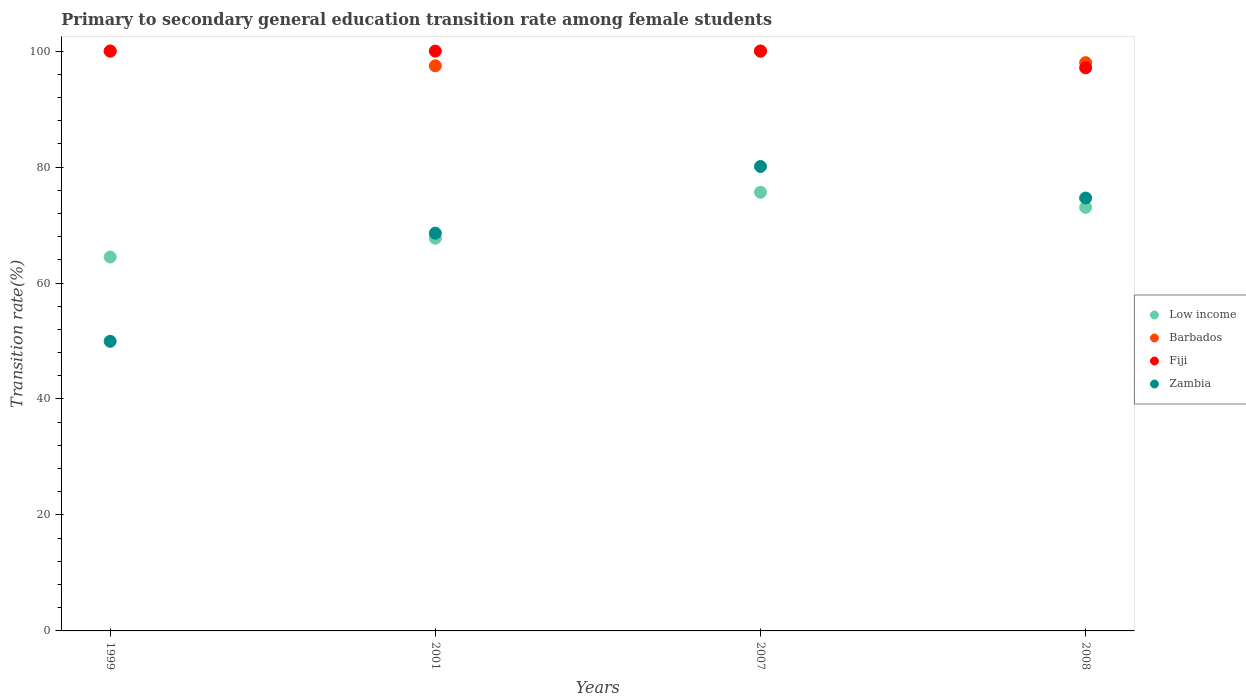How many different coloured dotlines are there?
Your answer should be very brief. 4. What is the transition rate in Low income in 2001?
Offer a terse response. 67.72. Across all years, what is the maximum transition rate in Barbados?
Keep it short and to the point. 100. Across all years, what is the minimum transition rate in Barbados?
Your answer should be compact. 97.46. In which year was the transition rate in Zambia maximum?
Ensure brevity in your answer.  2007. In which year was the transition rate in Zambia minimum?
Offer a very short reply. 1999. What is the total transition rate in Barbados in the graph?
Make the answer very short. 395.46. What is the difference between the transition rate in Zambia in 2001 and that in 2007?
Offer a very short reply. -11.5. What is the difference between the transition rate in Barbados in 1999 and the transition rate in Zambia in 2001?
Offer a very short reply. 31.4. What is the average transition rate in Barbados per year?
Keep it short and to the point. 98.87. In the year 2007, what is the difference between the transition rate in Barbados and transition rate in Zambia?
Your answer should be very brief. 19.9. What is the ratio of the transition rate in Low income in 1999 to that in 2007?
Your answer should be compact. 0.85. Is the transition rate in Zambia in 2007 less than that in 2008?
Make the answer very short. No. What is the difference between the highest and the second highest transition rate in Fiji?
Ensure brevity in your answer.  0. What is the difference between the highest and the lowest transition rate in Zambia?
Make the answer very short. 30.15. In how many years, is the transition rate in Barbados greater than the average transition rate in Barbados taken over all years?
Ensure brevity in your answer.  2. Is the sum of the transition rate in Zambia in 2001 and 2008 greater than the maximum transition rate in Low income across all years?
Provide a succinct answer. Yes. Does the transition rate in Fiji monotonically increase over the years?
Offer a very short reply. No. How many dotlines are there?
Offer a very short reply. 4. How many years are there in the graph?
Your answer should be compact. 4. What is the difference between two consecutive major ticks on the Y-axis?
Your response must be concise. 20. Are the values on the major ticks of Y-axis written in scientific E-notation?
Give a very brief answer. No. Does the graph contain any zero values?
Offer a terse response. No. Does the graph contain grids?
Provide a succinct answer. No. How are the legend labels stacked?
Make the answer very short. Vertical. What is the title of the graph?
Keep it short and to the point. Primary to secondary general education transition rate among female students. Does "Ethiopia" appear as one of the legend labels in the graph?
Keep it short and to the point. No. What is the label or title of the X-axis?
Make the answer very short. Years. What is the label or title of the Y-axis?
Offer a very short reply. Transition rate(%). What is the Transition rate(%) of Low income in 1999?
Provide a short and direct response. 64.48. What is the Transition rate(%) in Fiji in 1999?
Offer a terse response. 100. What is the Transition rate(%) of Zambia in 1999?
Your response must be concise. 49.95. What is the Transition rate(%) of Low income in 2001?
Provide a succinct answer. 67.72. What is the Transition rate(%) in Barbados in 2001?
Give a very brief answer. 97.46. What is the Transition rate(%) of Fiji in 2001?
Make the answer very short. 100. What is the Transition rate(%) of Zambia in 2001?
Make the answer very short. 68.6. What is the Transition rate(%) of Low income in 2007?
Your response must be concise. 75.65. What is the Transition rate(%) in Fiji in 2007?
Your response must be concise. 100. What is the Transition rate(%) of Zambia in 2007?
Offer a terse response. 80.1. What is the Transition rate(%) in Low income in 2008?
Offer a very short reply. 73.05. What is the Transition rate(%) in Barbados in 2008?
Offer a very short reply. 98. What is the Transition rate(%) of Fiji in 2008?
Ensure brevity in your answer.  97.11. What is the Transition rate(%) in Zambia in 2008?
Offer a very short reply. 74.66. Across all years, what is the maximum Transition rate(%) of Low income?
Offer a very short reply. 75.65. Across all years, what is the maximum Transition rate(%) in Barbados?
Your answer should be very brief. 100. Across all years, what is the maximum Transition rate(%) in Fiji?
Give a very brief answer. 100. Across all years, what is the maximum Transition rate(%) in Zambia?
Your answer should be compact. 80.1. Across all years, what is the minimum Transition rate(%) of Low income?
Provide a short and direct response. 64.48. Across all years, what is the minimum Transition rate(%) in Barbados?
Keep it short and to the point. 97.46. Across all years, what is the minimum Transition rate(%) of Fiji?
Your response must be concise. 97.11. Across all years, what is the minimum Transition rate(%) of Zambia?
Make the answer very short. 49.95. What is the total Transition rate(%) in Low income in the graph?
Provide a short and direct response. 280.91. What is the total Transition rate(%) of Barbados in the graph?
Provide a short and direct response. 395.46. What is the total Transition rate(%) of Fiji in the graph?
Keep it short and to the point. 397.11. What is the total Transition rate(%) in Zambia in the graph?
Your response must be concise. 273.3. What is the difference between the Transition rate(%) in Low income in 1999 and that in 2001?
Offer a very short reply. -3.24. What is the difference between the Transition rate(%) in Barbados in 1999 and that in 2001?
Your answer should be compact. 2.54. What is the difference between the Transition rate(%) in Fiji in 1999 and that in 2001?
Provide a succinct answer. 0. What is the difference between the Transition rate(%) of Zambia in 1999 and that in 2001?
Your answer should be compact. -18.65. What is the difference between the Transition rate(%) in Low income in 1999 and that in 2007?
Give a very brief answer. -11.17. What is the difference between the Transition rate(%) of Barbados in 1999 and that in 2007?
Give a very brief answer. 0. What is the difference between the Transition rate(%) in Zambia in 1999 and that in 2007?
Provide a succinct answer. -30.15. What is the difference between the Transition rate(%) of Low income in 1999 and that in 2008?
Provide a short and direct response. -8.57. What is the difference between the Transition rate(%) of Barbados in 1999 and that in 2008?
Offer a very short reply. 2. What is the difference between the Transition rate(%) of Fiji in 1999 and that in 2008?
Give a very brief answer. 2.89. What is the difference between the Transition rate(%) in Zambia in 1999 and that in 2008?
Provide a succinct answer. -24.71. What is the difference between the Transition rate(%) of Low income in 2001 and that in 2007?
Offer a terse response. -7.93. What is the difference between the Transition rate(%) in Barbados in 2001 and that in 2007?
Make the answer very short. -2.54. What is the difference between the Transition rate(%) of Fiji in 2001 and that in 2007?
Offer a terse response. 0. What is the difference between the Transition rate(%) in Zambia in 2001 and that in 2007?
Provide a succinct answer. -11.5. What is the difference between the Transition rate(%) of Low income in 2001 and that in 2008?
Provide a succinct answer. -5.33. What is the difference between the Transition rate(%) in Barbados in 2001 and that in 2008?
Your answer should be very brief. -0.54. What is the difference between the Transition rate(%) of Fiji in 2001 and that in 2008?
Your answer should be very brief. 2.89. What is the difference between the Transition rate(%) in Zambia in 2001 and that in 2008?
Your response must be concise. -6.06. What is the difference between the Transition rate(%) in Low income in 2007 and that in 2008?
Provide a succinct answer. 2.6. What is the difference between the Transition rate(%) in Barbados in 2007 and that in 2008?
Your response must be concise. 2. What is the difference between the Transition rate(%) of Fiji in 2007 and that in 2008?
Offer a terse response. 2.89. What is the difference between the Transition rate(%) of Zambia in 2007 and that in 2008?
Keep it short and to the point. 5.44. What is the difference between the Transition rate(%) of Low income in 1999 and the Transition rate(%) of Barbados in 2001?
Offer a terse response. -32.98. What is the difference between the Transition rate(%) of Low income in 1999 and the Transition rate(%) of Fiji in 2001?
Provide a short and direct response. -35.52. What is the difference between the Transition rate(%) in Low income in 1999 and the Transition rate(%) in Zambia in 2001?
Keep it short and to the point. -4.11. What is the difference between the Transition rate(%) in Barbados in 1999 and the Transition rate(%) in Zambia in 2001?
Your answer should be very brief. 31.4. What is the difference between the Transition rate(%) of Fiji in 1999 and the Transition rate(%) of Zambia in 2001?
Your answer should be compact. 31.4. What is the difference between the Transition rate(%) in Low income in 1999 and the Transition rate(%) in Barbados in 2007?
Give a very brief answer. -35.52. What is the difference between the Transition rate(%) in Low income in 1999 and the Transition rate(%) in Fiji in 2007?
Your answer should be compact. -35.52. What is the difference between the Transition rate(%) of Low income in 1999 and the Transition rate(%) of Zambia in 2007?
Ensure brevity in your answer.  -15.61. What is the difference between the Transition rate(%) in Barbados in 1999 and the Transition rate(%) in Fiji in 2007?
Offer a terse response. 0. What is the difference between the Transition rate(%) of Barbados in 1999 and the Transition rate(%) of Zambia in 2007?
Ensure brevity in your answer.  19.9. What is the difference between the Transition rate(%) in Fiji in 1999 and the Transition rate(%) in Zambia in 2007?
Give a very brief answer. 19.9. What is the difference between the Transition rate(%) of Low income in 1999 and the Transition rate(%) of Barbados in 2008?
Your response must be concise. -33.52. What is the difference between the Transition rate(%) in Low income in 1999 and the Transition rate(%) in Fiji in 2008?
Provide a succinct answer. -32.63. What is the difference between the Transition rate(%) of Low income in 1999 and the Transition rate(%) of Zambia in 2008?
Offer a very short reply. -10.17. What is the difference between the Transition rate(%) of Barbados in 1999 and the Transition rate(%) of Fiji in 2008?
Your response must be concise. 2.89. What is the difference between the Transition rate(%) of Barbados in 1999 and the Transition rate(%) of Zambia in 2008?
Offer a terse response. 25.34. What is the difference between the Transition rate(%) of Fiji in 1999 and the Transition rate(%) of Zambia in 2008?
Your answer should be compact. 25.34. What is the difference between the Transition rate(%) of Low income in 2001 and the Transition rate(%) of Barbados in 2007?
Give a very brief answer. -32.28. What is the difference between the Transition rate(%) in Low income in 2001 and the Transition rate(%) in Fiji in 2007?
Your answer should be compact. -32.28. What is the difference between the Transition rate(%) in Low income in 2001 and the Transition rate(%) in Zambia in 2007?
Keep it short and to the point. -12.38. What is the difference between the Transition rate(%) of Barbados in 2001 and the Transition rate(%) of Fiji in 2007?
Your answer should be compact. -2.54. What is the difference between the Transition rate(%) in Barbados in 2001 and the Transition rate(%) in Zambia in 2007?
Provide a succinct answer. 17.36. What is the difference between the Transition rate(%) in Fiji in 2001 and the Transition rate(%) in Zambia in 2007?
Your response must be concise. 19.9. What is the difference between the Transition rate(%) of Low income in 2001 and the Transition rate(%) of Barbados in 2008?
Make the answer very short. -30.28. What is the difference between the Transition rate(%) of Low income in 2001 and the Transition rate(%) of Fiji in 2008?
Give a very brief answer. -29.39. What is the difference between the Transition rate(%) in Low income in 2001 and the Transition rate(%) in Zambia in 2008?
Ensure brevity in your answer.  -6.94. What is the difference between the Transition rate(%) in Barbados in 2001 and the Transition rate(%) in Fiji in 2008?
Offer a very short reply. 0.35. What is the difference between the Transition rate(%) of Barbados in 2001 and the Transition rate(%) of Zambia in 2008?
Give a very brief answer. 22.8. What is the difference between the Transition rate(%) in Fiji in 2001 and the Transition rate(%) in Zambia in 2008?
Make the answer very short. 25.34. What is the difference between the Transition rate(%) in Low income in 2007 and the Transition rate(%) in Barbados in 2008?
Provide a short and direct response. -22.35. What is the difference between the Transition rate(%) in Low income in 2007 and the Transition rate(%) in Fiji in 2008?
Offer a very short reply. -21.46. What is the difference between the Transition rate(%) in Low income in 2007 and the Transition rate(%) in Zambia in 2008?
Your answer should be very brief. 0.99. What is the difference between the Transition rate(%) of Barbados in 2007 and the Transition rate(%) of Fiji in 2008?
Offer a terse response. 2.89. What is the difference between the Transition rate(%) of Barbados in 2007 and the Transition rate(%) of Zambia in 2008?
Your answer should be compact. 25.34. What is the difference between the Transition rate(%) of Fiji in 2007 and the Transition rate(%) of Zambia in 2008?
Ensure brevity in your answer.  25.34. What is the average Transition rate(%) in Low income per year?
Give a very brief answer. 70.23. What is the average Transition rate(%) of Barbados per year?
Offer a very short reply. 98.87. What is the average Transition rate(%) in Fiji per year?
Your response must be concise. 99.28. What is the average Transition rate(%) in Zambia per year?
Offer a terse response. 68.32. In the year 1999, what is the difference between the Transition rate(%) of Low income and Transition rate(%) of Barbados?
Your answer should be compact. -35.52. In the year 1999, what is the difference between the Transition rate(%) of Low income and Transition rate(%) of Fiji?
Give a very brief answer. -35.52. In the year 1999, what is the difference between the Transition rate(%) in Low income and Transition rate(%) in Zambia?
Give a very brief answer. 14.53. In the year 1999, what is the difference between the Transition rate(%) of Barbados and Transition rate(%) of Zambia?
Your answer should be compact. 50.05. In the year 1999, what is the difference between the Transition rate(%) in Fiji and Transition rate(%) in Zambia?
Give a very brief answer. 50.05. In the year 2001, what is the difference between the Transition rate(%) of Low income and Transition rate(%) of Barbados?
Make the answer very short. -29.74. In the year 2001, what is the difference between the Transition rate(%) in Low income and Transition rate(%) in Fiji?
Your answer should be very brief. -32.28. In the year 2001, what is the difference between the Transition rate(%) of Low income and Transition rate(%) of Zambia?
Offer a terse response. -0.87. In the year 2001, what is the difference between the Transition rate(%) in Barbados and Transition rate(%) in Fiji?
Offer a terse response. -2.54. In the year 2001, what is the difference between the Transition rate(%) of Barbados and Transition rate(%) of Zambia?
Make the answer very short. 28.86. In the year 2001, what is the difference between the Transition rate(%) in Fiji and Transition rate(%) in Zambia?
Offer a very short reply. 31.4. In the year 2007, what is the difference between the Transition rate(%) in Low income and Transition rate(%) in Barbados?
Offer a terse response. -24.35. In the year 2007, what is the difference between the Transition rate(%) in Low income and Transition rate(%) in Fiji?
Keep it short and to the point. -24.35. In the year 2007, what is the difference between the Transition rate(%) in Low income and Transition rate(%) in Zambia?
Your answer should be very brief. -4.45. In the year 2007, what is the difference between the Transition rate(%) in Barbados and Transition rate(%) in Zambia?
Ensure brevity in your answer.  19.9. In the year 2007, what is the difference between the Transition rate(%) of Fiji and Transition rate(%) of Zambia?
Provide a succinct answer. 19.9. In the year 2008, what is the difference between the Transition rate(%) in Low income and Transition rate(%) in Barbados?
Your answer should be very brief. -24.95. In the year 2008, what is the difference between the Transition rate(%) of Low income and Transition rate(%) of Fiji?
Ensure brevity in your answer.  -24.06. In the year 2008, what is the difference between the Transition rate(%) in Low income and Transition rate(%) in Zambia?
Offer a very short reply. -1.61. In the year 2008, what is the difference between the Transition rate(%) in Barbados and Transition rate(%) in Fiji?
Provide a short and direct response. 0.89. In the year 2008, what is the difference between the Transition rate(%) in Barbados and Transition rate(%) in Zambia?
Keep it short and to the point. 23.35. In the year 2008, what is the difference between the Transition rate(%) of Fiji and Transition rate(%) of Zambia?
Provide a succinct answer. 22.45. What is the ratio of the Transition rate(%) in Low income in 1999 to that in 2001?
Your answer should be very brief. 0.95. What is the ratio of the Transition rate(%) in Barbados in 1999 to that in 2001?
Provide a short and direct response. 1.03. What is the ratio of the Transition rate(%) of Fiji in 1999 to that in 2001?
Offer a terse response. 1. What is the ratio of the Transition rate(%) in Zambia in 1999 to that in 2001?
Provide a short and direct response. 0.73. What is the ratio of the Transition rate(%) of Low income in 1999 to that in 2007?
Your response must be concise. 0.85. What is the ratio of the Transition rate(%) in Barbados in 1999 to that in 2007?
Your response must be concise. 1. What is the ratio of the Transition rate(%) in Zambia in 1999 to that in 2007?
Provide a succinct answer. 0.62. What is the ratio of the Transition rate(%) of Low income in 1999 to that in 2008?
Your answer should be very brief. 0.88. What is the ratio of the Transition rate(%) of Barbados in 1999 to that in 2008?
Give a very brief answer. 1.02. What is the ratio of the Transition rate(%) of Fiji in 1999 to that in 2008?
Offer a terse response. 1.03. What is the ratio of the Transition rate(%) of Zambia in 1999 to that in 2008?
Provide a succinct answer. 0.67. What is the ratio of the Transition rate(%) in Low income in 2001 to that in 2007?
Ensure brevity in your answer.  0.9. What is the ratio of the Transition rate(%) of Barbados in 2001 to that in 2007?
Your answer should be very brief. 0.97. What is the ratio of the Transition rate(%) of Fiji in 2001 to that in 2007?
Give a very brief answer. 1. What is the ratio of the Transition rate(%) in Zambia in 2001 to that in 2007?
Offer a terse response. 0.86. What is the ratio of the Transition rate(%) in Low income in 2001 to that in 2008?
Make the answer very short. 0.93. What is the ratio of the Transition rate(%) of Barbados in 2001 to that in 2008?
Your answer should be very brief. 0.99. What is the ratio of the Transition rate(%) of Fiji in 2001 to that in 2008?
Keep it short and to the point. 1.03. What is the ratio of the Transition rate(%) of Zambia in 2001 to that in 2008?
Provide a short and direct response. 0.92. What is the ratio of the Transition rate(%) of Low income in 2007 to that in 2008?
Give a very brief answer. 1.04. What is the ratio of the Transition rate(%) in Barbados in 2007 to that in 2008?
Ensure brevity in your answer.  1.02. What is the ratio of the Transition rate(%) of Fiji in 2007 to that in 2008?
Your response must be concise. 1.03. What is the ratio of the Transition rate(%) in Zambia in 2007 to that in 2008?
Give a very brief answer. 1.07. What is the difference between the highest and the second highest Transition rate(%) of Low income?
Provide a succinct answer. 2.6. What is the difference between the highest and the second highest Transition rate(%) of Barbados?
Your answer should be compact. 0. What is the difference between the highest and the second highest Transition rate(%) of Fiji?
Your response must be concise. 0. What is the difference between the highest and the second highest Transition rate(%) in Zambia?
Offer a very short reply. 5.44. What is the difference between the highest and the lowest Transition rate(%) in Low income?
Your answer should be compact. 11.17. What is the difference between the highest and the lowest Transition rate(%) in Barbados?
Provide a short and direct response. 2.54. What is the difference between the highest and the lowest Transition rate(%) of Fiji?
Your answer should be very brief. 2.89. What is the difference between the highest and the lowest Transition rate(%) of Zambia?
Your response must be concise. 30.15. 